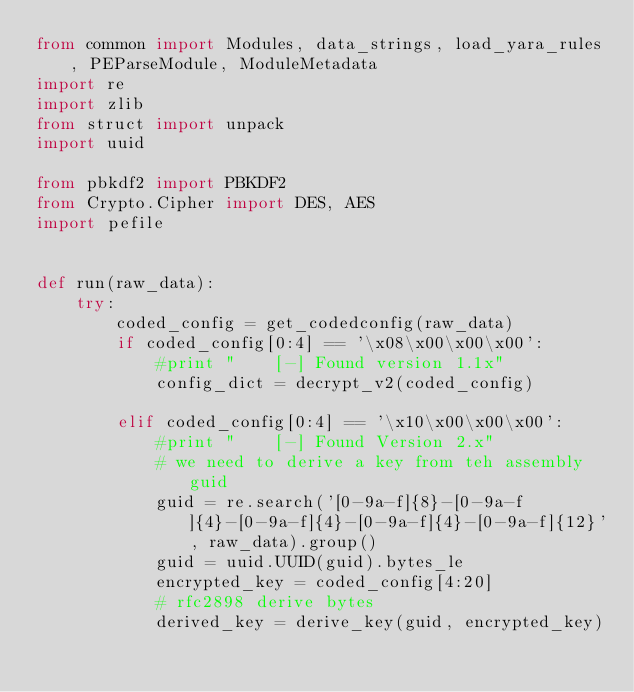Convert code to text. <code><loc_0><loc_0><loc_500><loc_500><_Python_>from common import Modules, data_strings, load_yara_rules, PEParseModule, ModuleMetadata
import re
import zlib
from struct import unpack
import uuid

from pbkdf2 import PBKDF2
from Crypto.Cipher import DES, AES
import pefile


def run(raw_data):
    try:
        coded_config = get_codedconfig(raw_data)
        if coded_config[0:4] == '\x08\x00\x00\x00':
            #print "    [-] Found version 1.1x"
            config_dict = decrypt_v2(coded_config)

        elif coded_config[0:4] == '\x10\x00\x00\x00':
            #print "    [-] Found Version 2.x"
            # we need to derive a key from teh assembly guid
            guid = re.search('[0-9a-f]{8}-[0-9a-f]{4}-[0-9a-f]{4}-[0-9a-f]{4}-[0-9a-f]{12}', raw_data).group()
            guid = uuid.UUID(guid).bytes_le
            encrypted_key = coded_config[4:20]
            # rfc2898 derive bytes
            derived_key = derive_key(guid, encrypted_key)</code> 